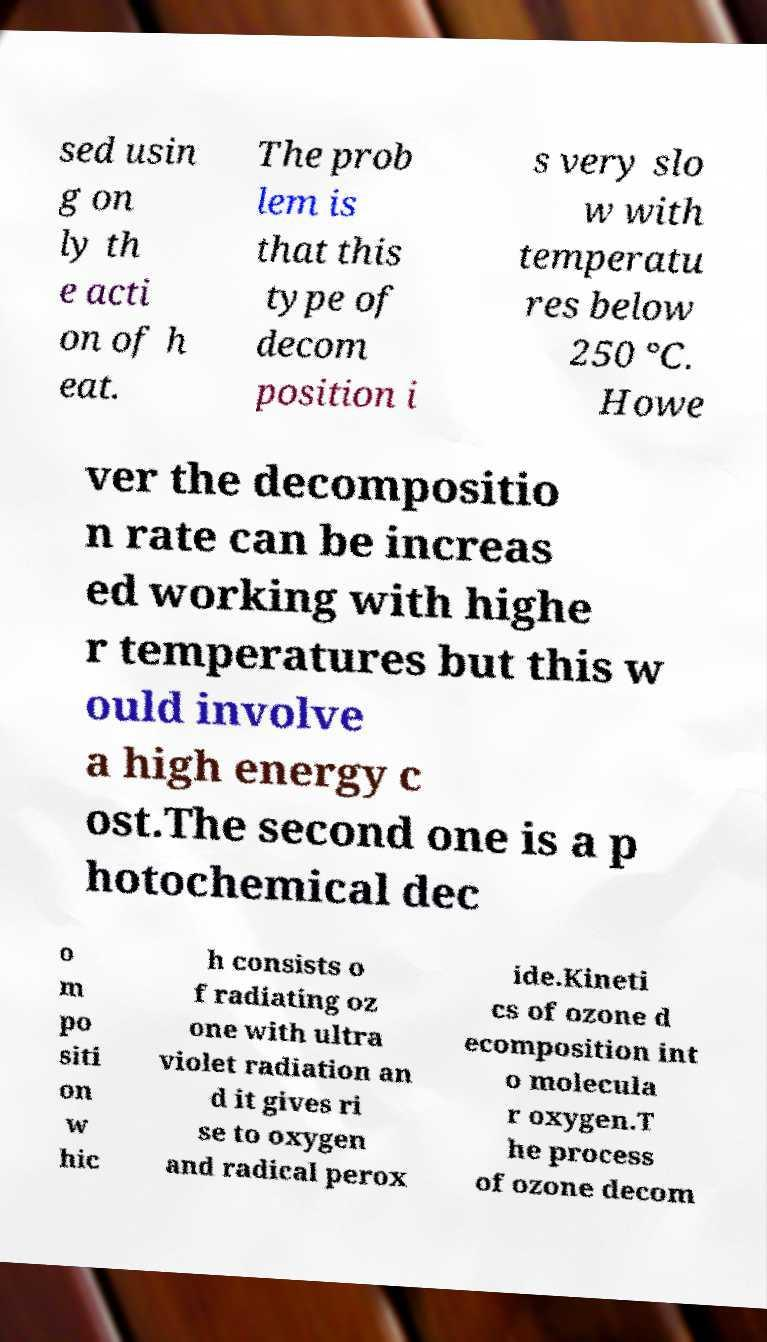I need the written content from this picture converted into text. Can you do that? sed usin g on ly th e acti on of h eat. The prob lem is that this type of decom position i s very slo w with temperatu res below 250 °C. Howe ver the decompositio n rate can be increas ed working with highe r temperatures but this w ould involve a high energy c ost.The second one is a p hotochemical dec o m po siti on w hic h consists o f radiating oz one with ultra violet radiation an d it gives ri se to oxygen and radical perox ide.Kineti cs of ozone d ecomposition int o molecula r oxygen.T he process of ozone decom 